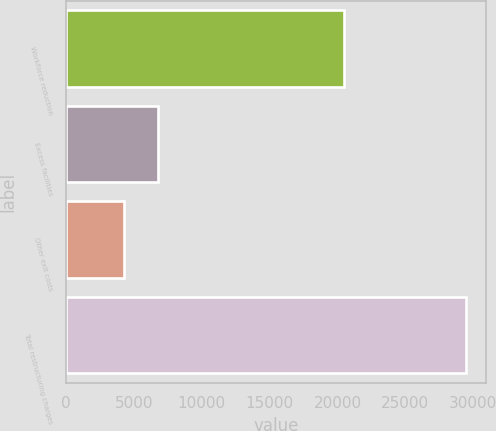Convert chart to OTSL. <chart><loc_0><loc_0><loc_500><loc_500><bar_chart><fcel>Workforce reduction<fcel>Excess facilities<fcel>Other exit costs<fcel>Total restructuring charges<nl><fcel>20497<fcel>6763.6<fcel>4244<fcel>29440<nl></chart> 